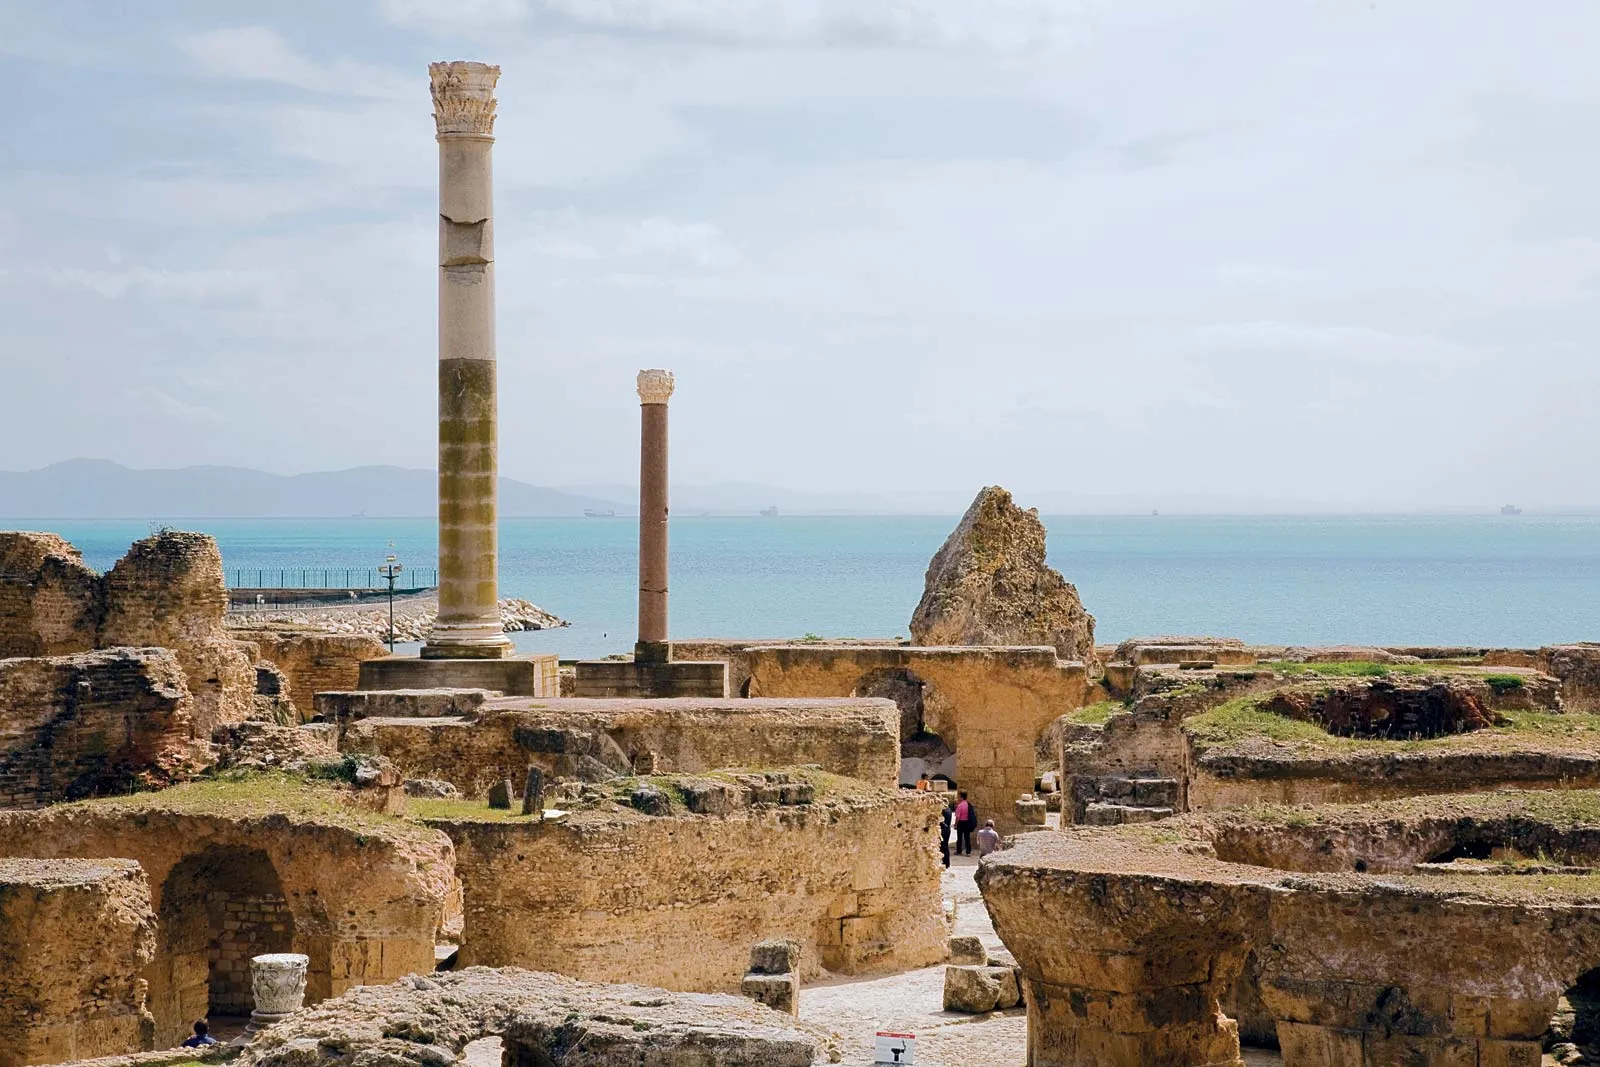Can you tell me more about the history of Carthage? Certainly! Carthage was founded by the Phoenician city of Tyre in the 9th century BC and became a powerful thalassocracy in the Mediterranean. The city was a hub for trade and commerce before it became famous for its conflicts with Rome during the Punic Wars. Eventually, it was destroyed by the Romans in 146 BC at the end of the Third Punic War, before later being re-established by Julius Caesar as a Roman colony. 